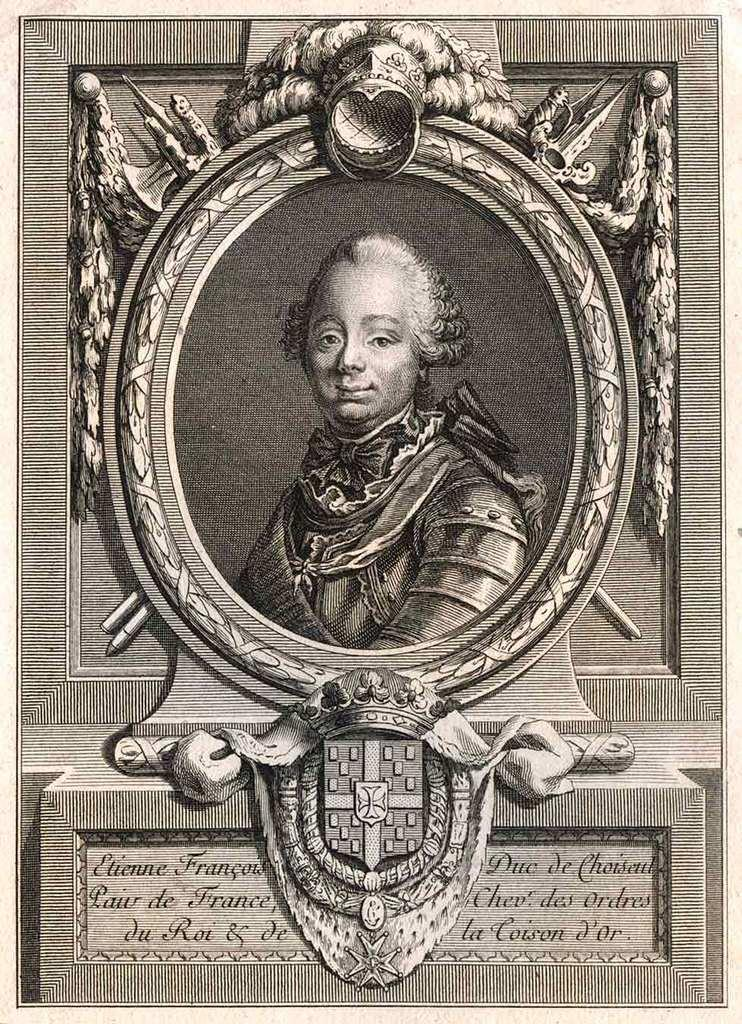<image>
Offer a succinct explanation of the picture presented. Old photograph showing a person and the name "Elienne" on the bottom. 